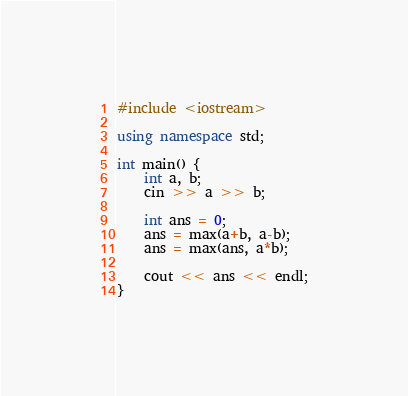Convert code to text. <code><loc_0><loc_0><loc_500><loc_500><_C++_>#include <iostream>

using namespace std;

int main() {
    int a, b;
    cin >> a >> b;

    int ans = 0;
    ans = max(a+b, a-b);
    ans = max(ans, a*b);

    cout << ans << endl;
}
</code> 